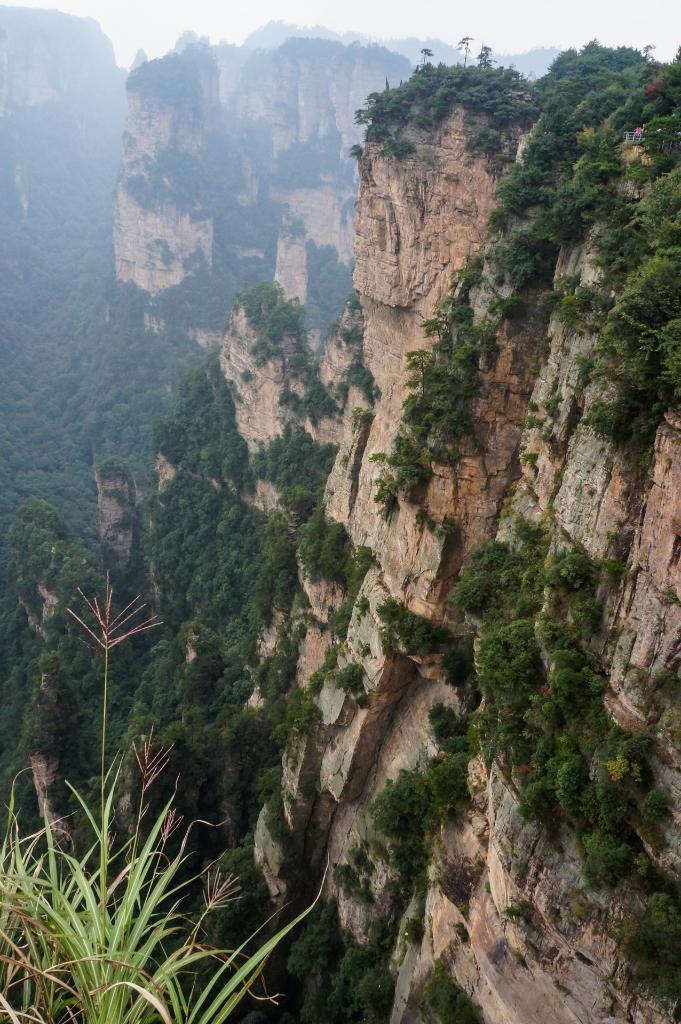What type of landscape is depicted in the image? The image features hills and many trees. What other types of vegetation can be seen in the image? There are also plants visible in the image. What part of the natural environment is visible in the image? The sky is visible in the image. Can you tell me how many yaks are grazing on the ground in the image? There are no yaks present in the image; it features hills, trees, and plants. What type of sensation can be experienced by touching the plants in the image? The image is a visual representation, and it is not possible to experience sensations such as touch through the image. 